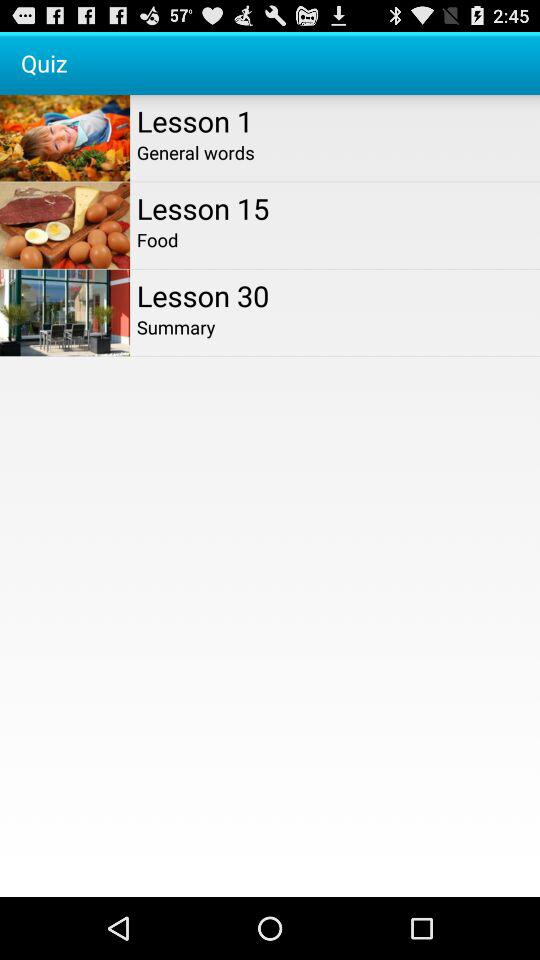What is there in lesson 1? There are "General words" in lesson 1. 